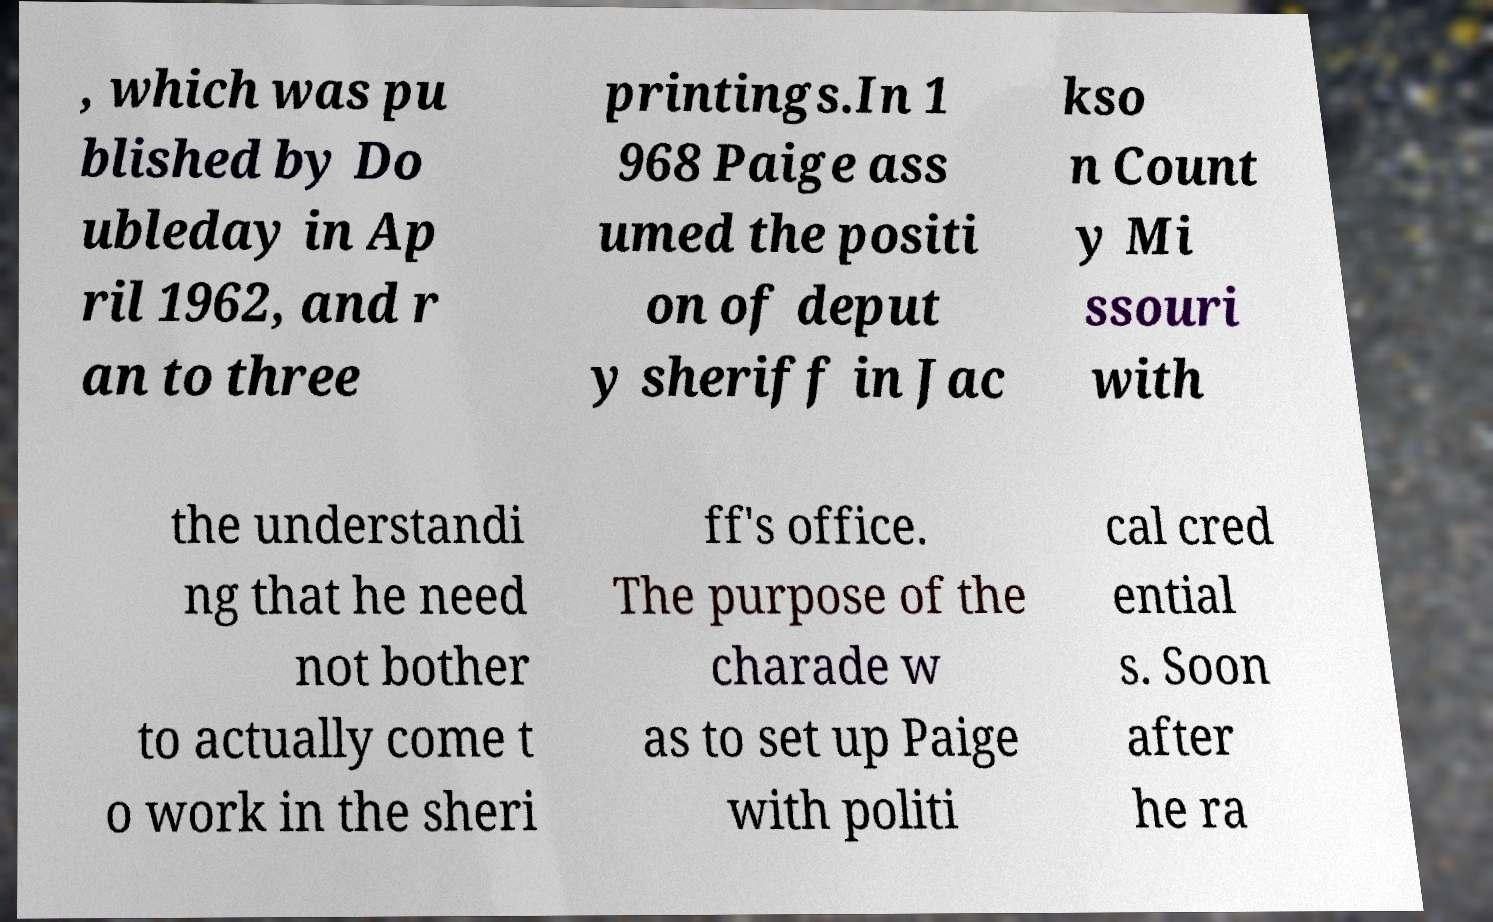Can you accurately transcribe the text from the provided image for me? , which was pu blished by Do ubleday in Ap ril 1962, and r an to three printings.In 1 968 Paige ass umed the positi on of deput y sheriff in Jac kso n Count y Mi ssouri with the understandi ng that he need not bother to actually come t o work in the sheri ff's office. The purpose of the charade w as to set up Paige with politi cal cred ential s. Soon after he ra 